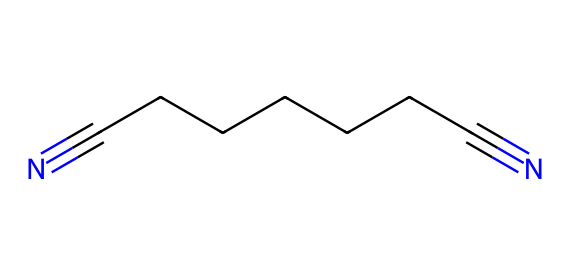What is the molecular formula of adiponitrile? The SMILES representation indicates the presence of two nitrile functional groups (-C≡N) at each end of a seven-carbon chain, suggesting the molecular formula C8H12N2.
Answer: C8H12N2 How many carbon atoms are in adiponitrile? From the SMILES string, we can count the number of carbon atoms represented in the chain, which consists of seven carbon atoms plus one at each end, totaling eight.
Answer: 8 What type of functional groups are present in adiponitrile? The presence of the -C≡N groups in the molecular structure (observed in the SMILES notation) indicates that it contains nitrile functional groups.
Answer: nitrile What is the significance of the nitrile groups in adiponitrile? Nitriles, like those in adiponitrile, are significant for their reactivity in various chemical processes, especially in polymer synthesis, such as nylon production.
Answer: nylon synthesis How many nitrogen atoms are present in adiponitrile? The SMILES string shows two -C≡N groups, each containing one nitrogen atom, indicating a total of two nitrogen atoms in the molecule.
Answer: 2 What type of reaction is adiponitrile commonly involved in? Adiponitrile is often involved in polymerization reactions, which are crucial for synthesizing materials like nylon.
Answer: polymerization What is the physical state of adiponitrile at room temperature? Adiponitrile is typically a liquid at room temperature, as indicated by its chemical structure and general knowledge of similar nitrile compounds.
Answer: liquid 